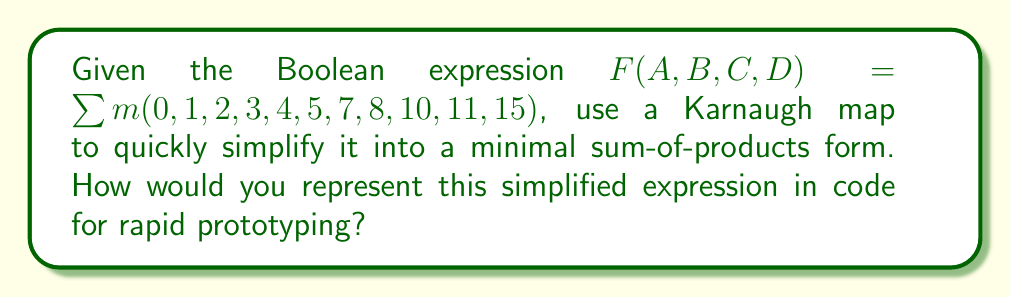Teach me how to tackle this problem. 1. Create a 4-variable Karnaugh map:

[asy]
unitsize(1cm);
defaultpen(fontsize(10pt));

for(int i=0; i<4; ++i) {
  for(int j=0; j<4; ++j) {
    draw((i,j)--(i+1,j)--(i+1,j+1)--(i,j+1)--cycle);
  }
}

label("00", (-0.5,3.5));
label("01", (-0.5,2.5));
label("11", (-0.5,1.5));
label("10", (-0.5,0.5));

label("00", (0.5,4.5));
label("01", (1.5,4.5));
label("11", (2.5,4.5));
label("10", (3.5,4.5));

label("1", (0.5,3.5));
label("1", (1.5,3.5));
label("1", (2.5,3.5));
label("1", (3.5,3.5));
label("1", (0.5,2.5));
label("1", (1.5,2.5));
label("0", (2.5,2.5));
label("1", (3.5,2.5));
label("0", (0.5,1.5));
label("1", (1.5,1.5));
label("1", (2.5,1.5));
label("0", (3.5,1.5));
label("1", (0.5,0.5));
label("0", (1.5,0.5));
label("0", (2.5,0.5));
label("1", (3.5,0.5));

label("AB", (-1.5,2));
label("CD", (2,-1));
[/asy]

2. Identify the largest possible groups of 1s:
   - Group of 8: $\overline{C}$ (top two rows)
   - Group of 2: $A\overline{B}D$ (bottom-right corner)
   - Single 1: $AB\overline{C}D$ (middle-right cell)

3. Write the simplified expression:
   $F = \overline{C} + A\overline{B}D + AB\overline{C}D$

4. For rapid prototyping in code, we can represent this as:
   ```
   F = (!C) | (A & !B & D) | (A & B & !C & D)
   ```
   Where `!` represents NOT, `&` represents AND, and `|` represents OR.

This simplified form allows for quick implementation and testing, aligning with the hacker mentality of rapid prototyping.
Answer: $F = \overline{C} + A\overline{B}D + AB\overline{C}D$ 